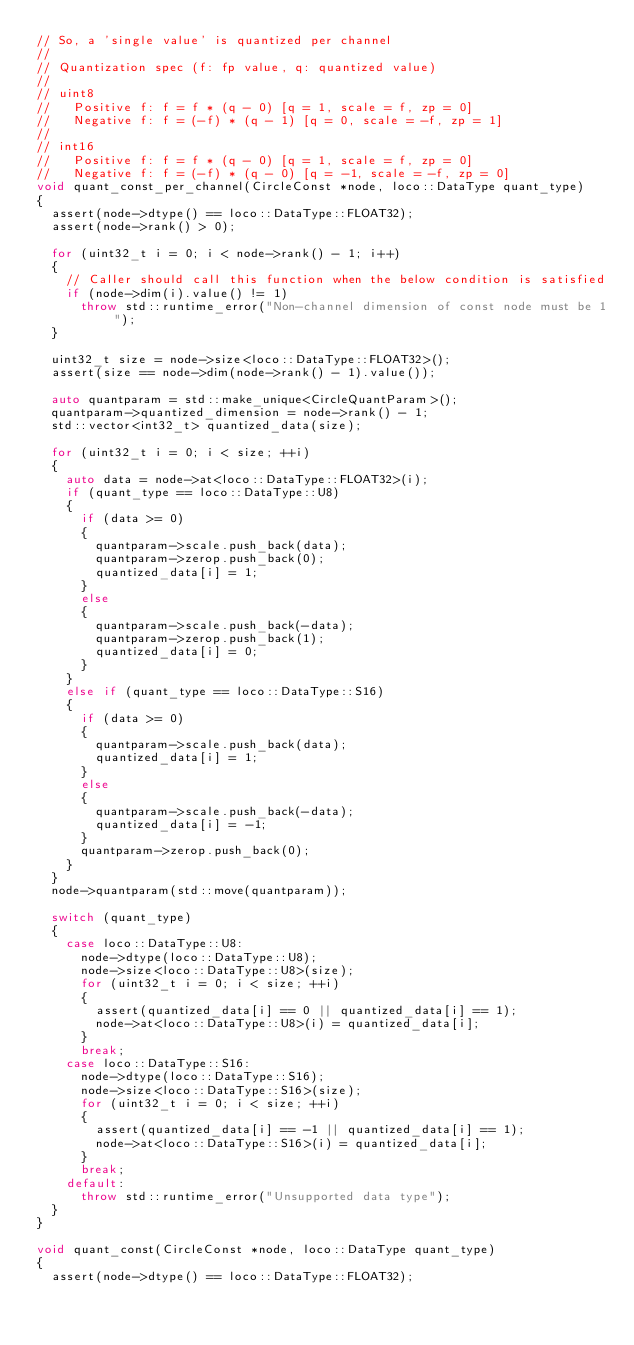<code> <loc_0><loc_0><loc_500><loc_500><_C++_>// So, a 'single value' is quantized per channel
//
// Quantization spec (f: fp value, q: quantized value)
//
// uint8
//   Positive f: f = f * (q - 0) [q = 1, scale = f, zp = 0]
//   Negative f: f = (-f) * (q - 1) [q = 0, scale = -f, zp = 1]
//
// int16
//   Positive f: f = f * (q - 0) [q = 1, scale = f, zp = 0]
//   Negative f: f = (-f) * (q - 0) [q = -1, scale = -f, zp = 0]
void quant_const_per_channel(CircleConst *node, loco::DataType quant_type)
{
  assert(node->dtype() == loco::DataType::FLOAT32);
  assert(node->rank() > 0);

  for (uint32_t i = 0; i < node->rank() - 1; i++)
  {
    // Caller should call this function when the below condition is satisfied
    if (node->dim(i).value() != 1)
      throw std::runtime_error("Non-channel dimension of const node must be 1");
  }

  uint32_t size = node->size<loco::DataType::FLOAT32>();
  assert(size == node->dim(node->rank() - 1).value());

  auto quantparam = std::make_unique<CircleQuantParam>();
  quantparam->quantized_dimension = node->rank() - 1;
  std::vector<int32_t> quantized_data(size);

  for (uint32_t i = 0; i < size; ++i)
  {
    auto data = node->at<loco::DataType::FLOAT32>(i);
    if (quant_type == loco::DataType::U8)
    {
      if (data >= 0)
      {
        quantparam->scale.push_back(data);
        quantparam->zerop.push_back(0);
        quantized_data[i] = 1;
      }
      else
      {
        quantparam->scale.push_back(-data);
        quantparam->zerop.push_back(1);
        quantized_data[i] = 0;
      }
    }
    else if (quant_type == loco::DataType::S16)
    {
      if (data >= 0)
      {
        quantparam->scale.push_back(data);
        quantized_data[i] = 1;
      }
      else
      {
        quantparam->scale.push_back(-data);
        quantized_data[i] = -1;
      }
      quantparam->zerop.push_back(0);
    }
  }
  node->quantparam(std::move(quantparam));

  switch (quant_type)
  {
    case loco::DataType::U8:
      node->dtype(loco::DataType::U8);
      node->size<loco::DataType::U8>(size);
      for (uint32_t i = 0; i < size; ++i)
      {
        assert(quantized_data[i] == 0 || quantized_data[i] == 1);
        node->at<loco::DataType::U8>(i) = quantized_data[i];
      }
      break;
    case loco::DataType::S16:
      node->dtype(loco::DataType::S16);
      node->size<loco::DataType::S16>(size);
      for (uint32_t i = 0; i < size; ++i)
      {
        assert(quantized_data[i] == -1 || quantized_data[i] == 1);
        node->at<loco::DataType::S16>(i) = quantized_data[i];
      }
      break;
    default:
      throw std::runtime_error("Unsupported data type");
  }
}

void quant_const(CircleConst *node, loco::DataType quant_type)
{
  assert(node->dtype() == loco::DataType::FLOAT32);
</code> 